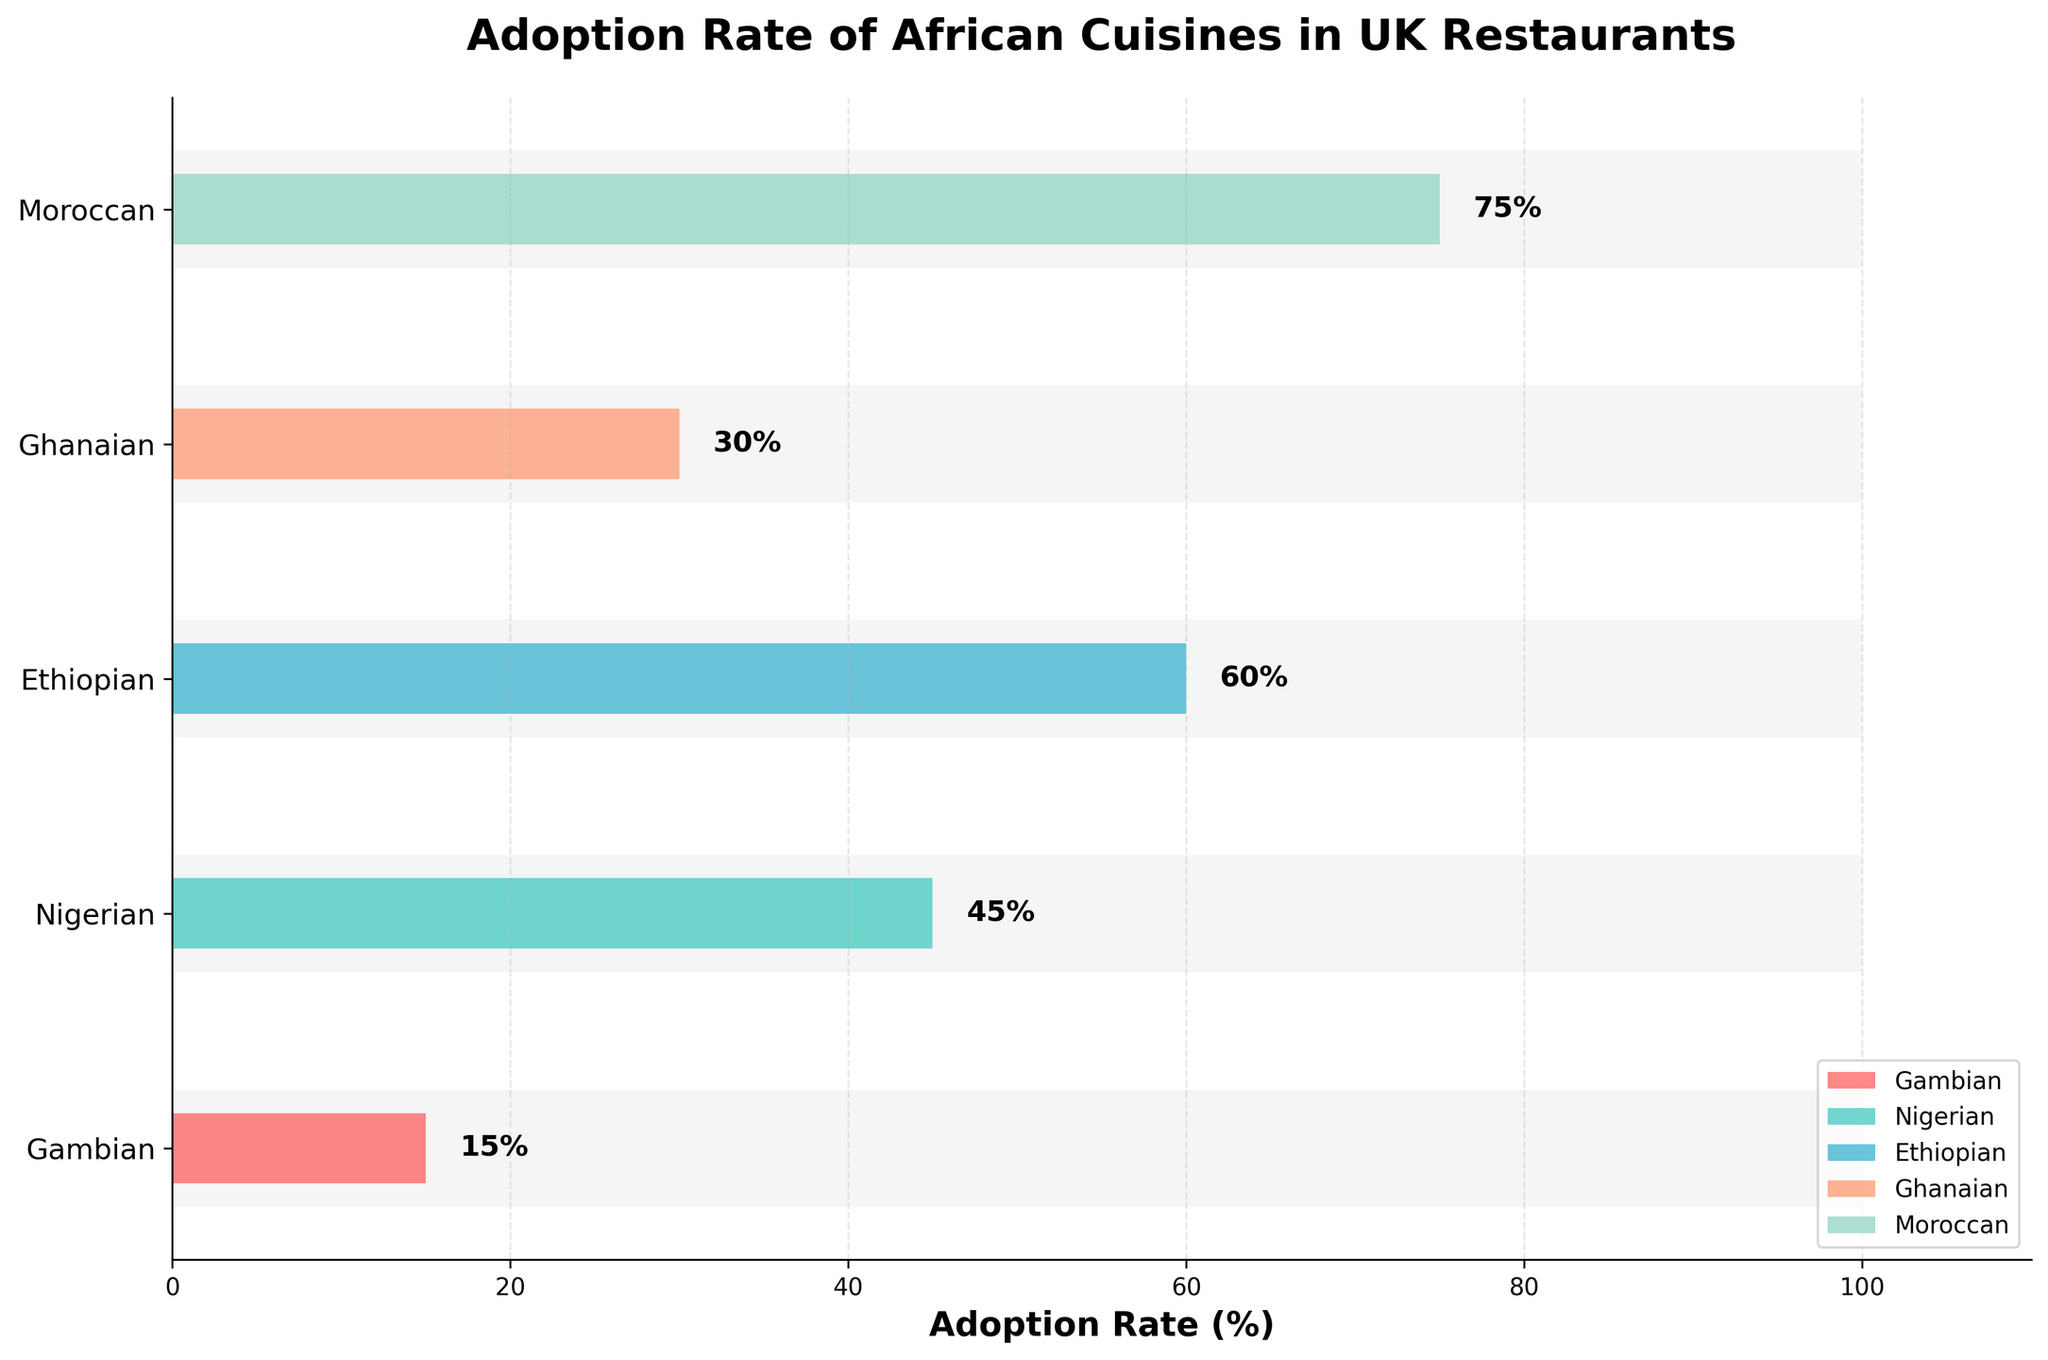What is the adoption rate of Gambian cuisine in UK restaurants? Look at the bar corresponding to Gambian cuisine and read the value at the end of the bar.
Answer: 15% Which cuisine has the highest adoption rate in UK restaurants? Compare the lengths of the bars for all cuisines; the longest bar indicates the highest adoption rate.
Answer: Moroccan How does the adoption rate of Gambian cuisine compare to Nigerian cuisine? Compare the length of the bars for Gambian and Nigerian cuisines. The Nigerian bar is significantly longer.
Answer: Lower What is the adoption rate difference between Ethiopian and Ghanaian cuisines? Subtract the adoption rate of Ghanaian cuisine from the adoption rate of Ethiopian cuisine.
Answer: 30% Which cuisines have a higher adoption rate than Gambian cuisine? Identify the bars longer than the Gambian cuisine bar. These are Nigerian, Ethiopian, Ghanaian, and Moroccan.
Answer: Nigerian, Ethiopian, Ghanaian, Moroccan By how much does the Moroccan cuisine adoption rate exceed the Gambian cuisine adoption rate? Subtract the adoption rate of Gambian cuisine from the adoption rate of Moroccan cuisine.
Answer: 60% What is the average adoption rate of all the cuisines shown in the plot? Sum all adoption rates and divide by the number of cuisines. (15 + 45 + 60 + 30 + 75) / 5
Answer: 45% Which cuisine falls exactly midpoint in terms of adoption rate? Arrange the adoption rates in ascending order and identify the middle value.
Answer: Ghanaian What is the overall adoption rate comparison value indicated in the bullet chart? Find the uniform comparison value provided in the background bars across all cuisines.
Answer: 100% Discuss the significance of the background comparison bars in the bullet chart. They provide a benchmark (set at 100%) against which the adoption rates of different cuisines are compared to indicate how each cuisine performs relative to an ideal or expected value in the UK restaurant scene.
Answer: Benchmark Comparison 